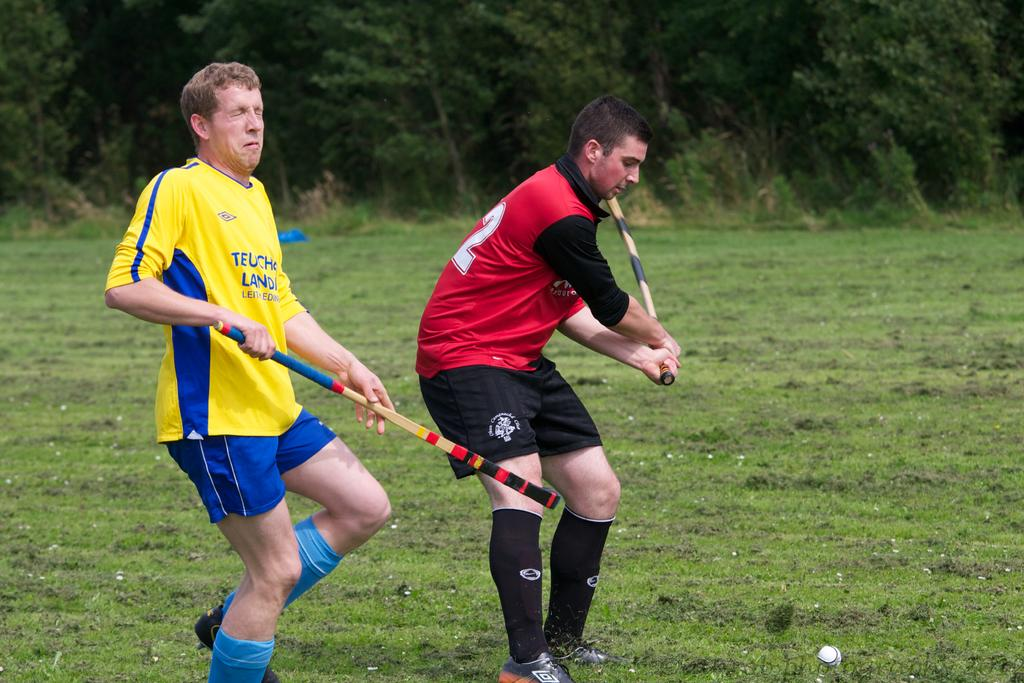What is the main subject of the image? The main subject of the image is men. What are the men doing in the image? The men are standing on the ground and holding bats in their hands. What can be seen in the background of the image? There is a ball and trees in the background of the image. What is the profit margin of the boats in the image? There are no boats present in the image, so it is not possible to determine the profit margin. 